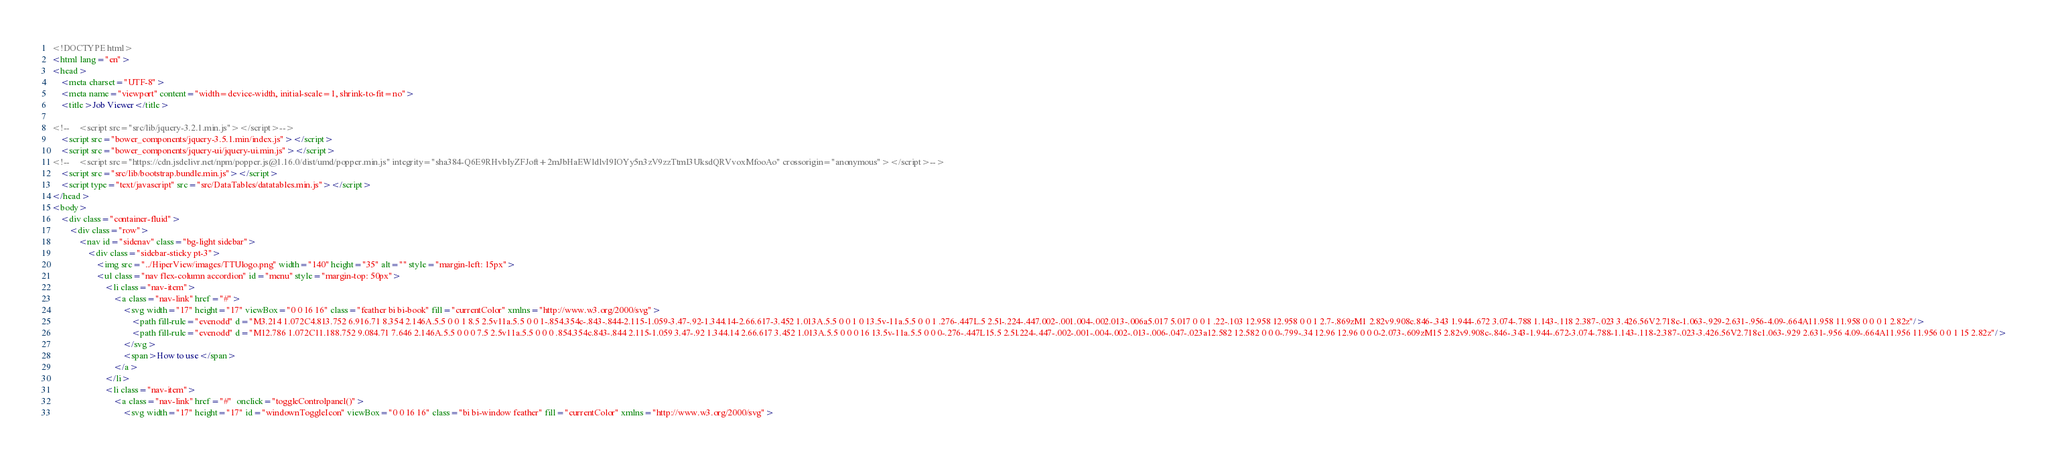Convert code to text. <code><loc_0><loc_0><loc_500><loc_500><_HTML_><!DOCTYPE html>
<html lang="en">
<head>
    <meta charset="UTF-8">
    <meta name="viewport" content="width=device-width, initial-scale=1, shrink-to-fit=no">
    <title>Job Viewer</title>

<!--    <script src="src/lib/jquery-3.2.1.min.js"></script>-->
    <script src="bower_components/jquery-3.5.1.min/index.js"></script>
    <script src="bower_components/jquery-ui/jquery-ui.min.js"></script>
<!--    <script src="https://cdn.jsdelivr.net/npm/popper.js@1.16.0/dist/umd/popper.min.js" integrity="sha384-Q6E9RHvbIyZFJoft+2mJbHaEWldlvI9IOYy5n3zV9zzTtmI3UksdQRVvoxMfooAo" crossorigin="anonymous"></script>-->
    <script src="src/lib/bootstrap.bundle.min.js"></script>
    <script type="text/javascript" src="src/DataTables/datatables.min.js"></script>
</head>
<body>
    <div class="container-fluid">
        <div class="row">
            <nav id="sidenav" class="bg-light sidebar">
                <div class="sidebar-sticky pt-3">
                    <img src="../HiperView/images/TTUlogo.png" width="140" height="35" alt="" style="margin-left: 15px">
                    <ul class="nav flex-column accordion" id="menu" style="margin-top: 50px">
                        <li class="nav-item">
                            <a class="nav-link" href="#">
                                <svg width="17" height="17" viewBox="0 0 16 16" class="feather bi bi-book" fill="currentColor" xmlns="http://www.w3.org/2000/svg">
                                    <path fill-rule="evenodd" d="M3.214 1.072C4.813.752 6.916.71 8.354 2.146A.5.5 0 0 1 8.5 2.5v11a.5.5 0 0 1-.854.354c-.843-.844-2.115-1.059-3.47-.92-1.344.14-2.66.617-3.452 1.013A.5.5 0 0 1 0 13.5v-11a.5.5 0 0 1 .276-.447L.5 2.5l-.224-.447.002-.001.004-.002.013-.006a5.017 5.017 0 0 1 .22-.103 12.958 12.958 0 0 1 2.7-.869zM1 2.82v9.908c.846-.343 1.944-.672 3.074-.788 1.143-.118 2.387-.023 3.426.56V2.718c-1.063-.929-2.631-.956-4.09-.664A11.958 11.958 0 0 0 1 2.82z"/>
                                    <path fill-rule="evenodd" d="M12.786 1.072C11.188.752 9.084.71 7.646 2.146A.5.5 0 0 0 7.5 2.5v11a.5.5 0 0 0 .854.354c.843-.844 2.115-1.059 3.47-.92 1.344.14 2.66.617 3.452 1.013A.5.5 0 0 0 16 13.5v-11a.5.5 0 0 0-.276-.447L15.5 2.5l.224-.447-.002-.001-.004-.002-.013-.006-.047-.023a12.582 12.582 0 0 0-.799-.34 12.96 12.96 0 0 0-2.073-.609zM15 2.82v9.908c-.846-.343-1.944-.672-3.074-.788-1.143-.118-2.387-.023-3.426.56V2.718c1.063-.929 2.631-.956 4.09-.664A11.956 11.956 0 0 1 15 2.82z"/>
                                </svg>
                                <span>How to use</span>
                            </a>
                        </li>
                        <li class="nav-item">
                            <a class="nav-link" href="#"  onclick="toggleControlpanel()">
                                <svg width="17" height="17" id="windownToggleIcon" viewBox="0 0 16 16" class="bi bi-window feather" fill="currentColor" xmlns="http://www.w3.org/2000/svg"></code> 